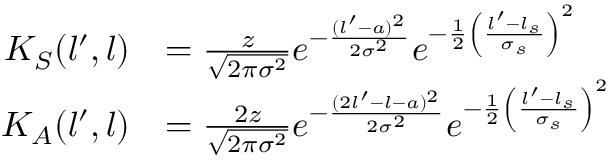Convert formula to latex. <formula><loc_0><loc_0><loc_500><loc_500>\begin{array} { r l } { K _ { S } ( l ^ { \prime } , l ) } & { = \frac { z } { \sqrt { 2 \pi \sigma ^ { 2 } } } e ^ { - \frac { ( l ^ { \prime } - a ) ^ { 2 } } { 2 \sigma ^ { 2 } } } e ^ { - \frac { 1 } { 2 } \left ( \frac { l ^ { \prime } - l _ { s } } { \sigma _ { s } } \right ) ^ { 2 } } } \\ { K _ { A } ( l ^ { \prime } , l ) } & { = \frac { 2 z } { \sqrt { 2 \pi \sigma ^ { 2 } } } e ^ { - \frac { ( 2 l ^ { \prime } - l - a ) ^ { 2 } } { 2 \sigma ^ { 2 } } } e ^ { - \frac { 1 } { 2 } \left ( \frac { l ^ { \prime } - l _ { s } } { \sigma _ { s } } \right ) ^ { 2 } } } \end{array}</formula> 